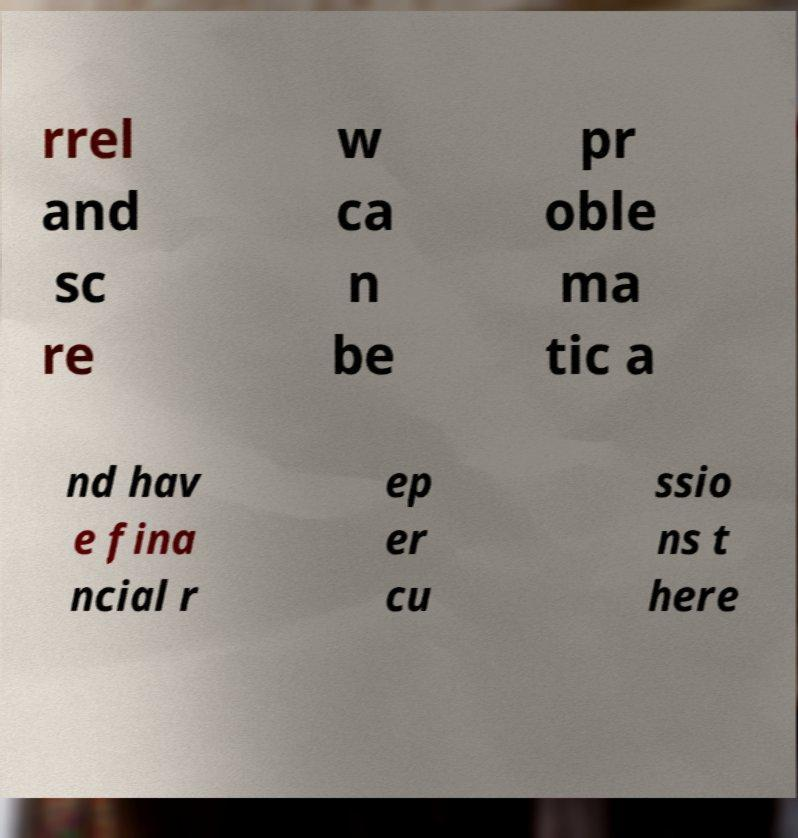Please read and relay the text visible in this image. What does it say? rrel and sc re w ca n be pr oble ma tic a nd hav e fina ncial r ep er cu ssio ns t here 